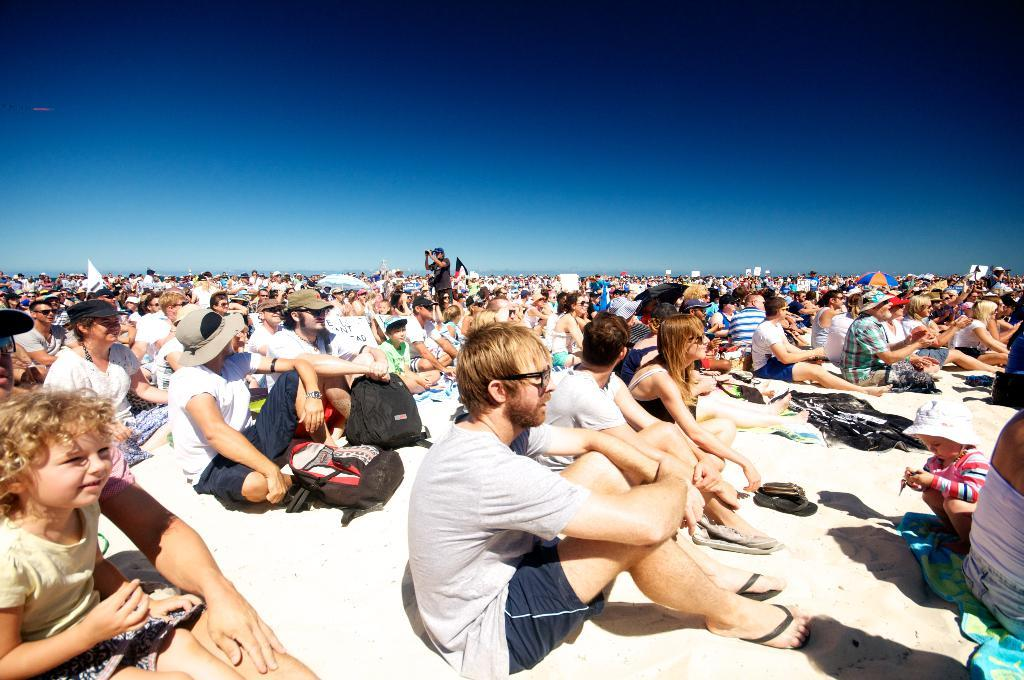What are the people in the image doing? There is a group of people sitting in the image. Is there anyone standing in the image? Yes, there is a person standing in the image. What is the standing person holding? The standing person is holding an object. What can be seen in the background of the image? The sky is visible in the background of the image. What colors are present in the sky? The sky is blue and white in color. What type of meat is being prepared by the laborer in the image? There is no laborer or meat present in the image. How can the group of people sitting in the image be helped? The image does not indicate any need for help, as the people are simply sitting. 